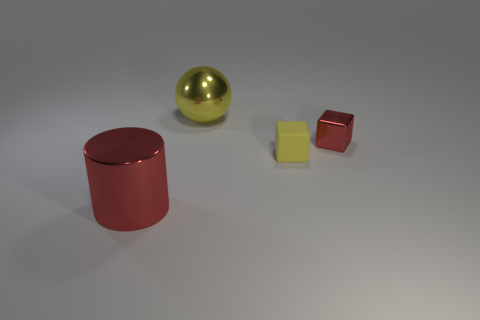Is there any other thing that is the same material as the yellow block?
Provide a short and direct response. No. Is there anything else that is the same shape as the big yellow object?
Provide a short and direct response. No. How many objects are either large objects or big yellow spheres?
Your answer should be compact. 2. Is there a small shiny thing of the same color as the metal sphere?
Make the answer very short. No. Are there fewer yellow objects than metallic things?
Your response must be concise. Yes. How many things are either tiny yellow matte cubes or yellow things that are in front of the small red metal cube?
Your response must be concise. 1. Are there any big yellow balls that have the same material as the tiny red object?
Keep it short and to the point. Yes. There is another yellow block that is the same size as the shiny cube; what material is it?
Make the answer very short. Rubber. There is a yellow object in front of the large object that is behind the tiny matte thing; what is it made of?
Your answer should be very brief. Rubber. Do the large metal thing that is in front of the large yellow sphere and the big yellow metallic thing have the same shape?
Your answer should be compact. No. 